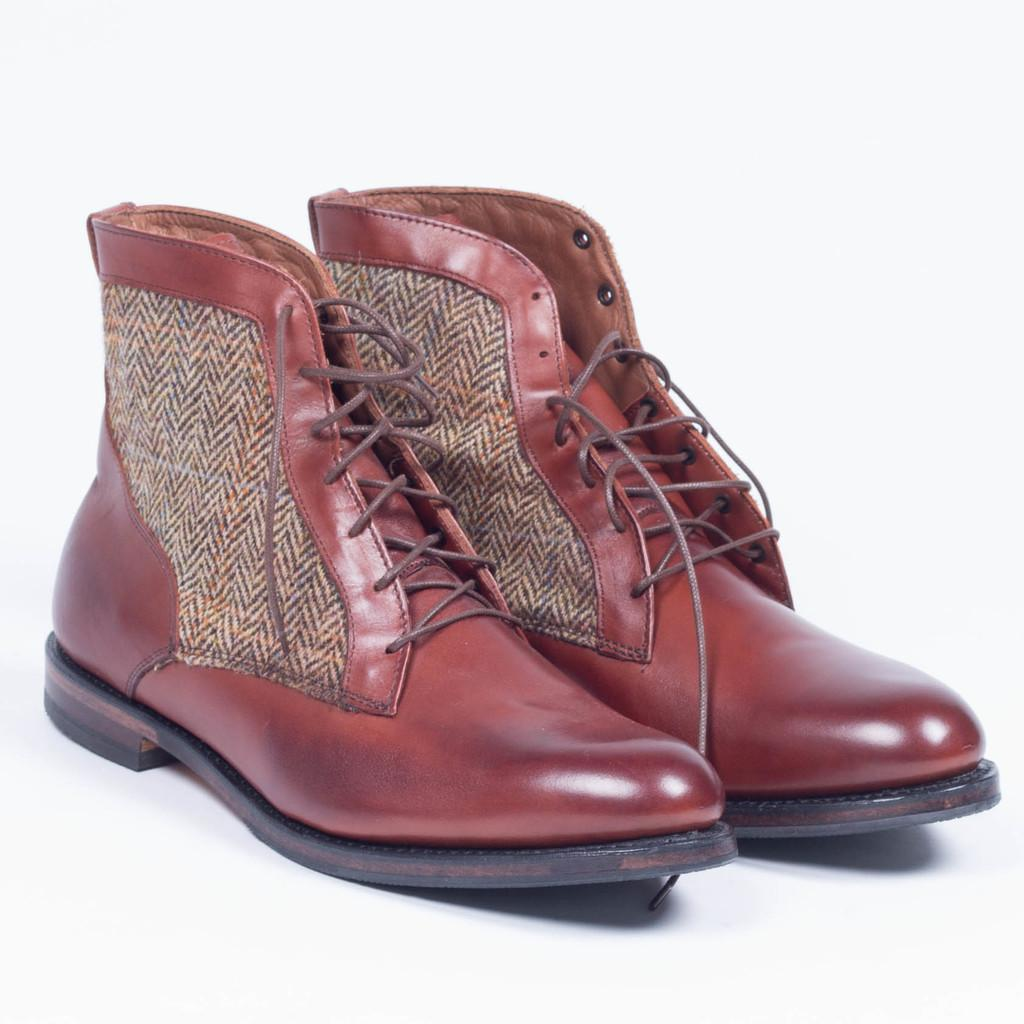What type of footwear is visible in the image? There is a pair of shoes in the image. What color are the shoes? The shoes are brown in color. On what surface are the shoes placed? The shoes are placed on a white surface. What is the color of the background in the image? The background of the image is white. How does the oven pull the shoes towards it in the image? There is no oven present in the image, and therefore no such interaction can be observed. 